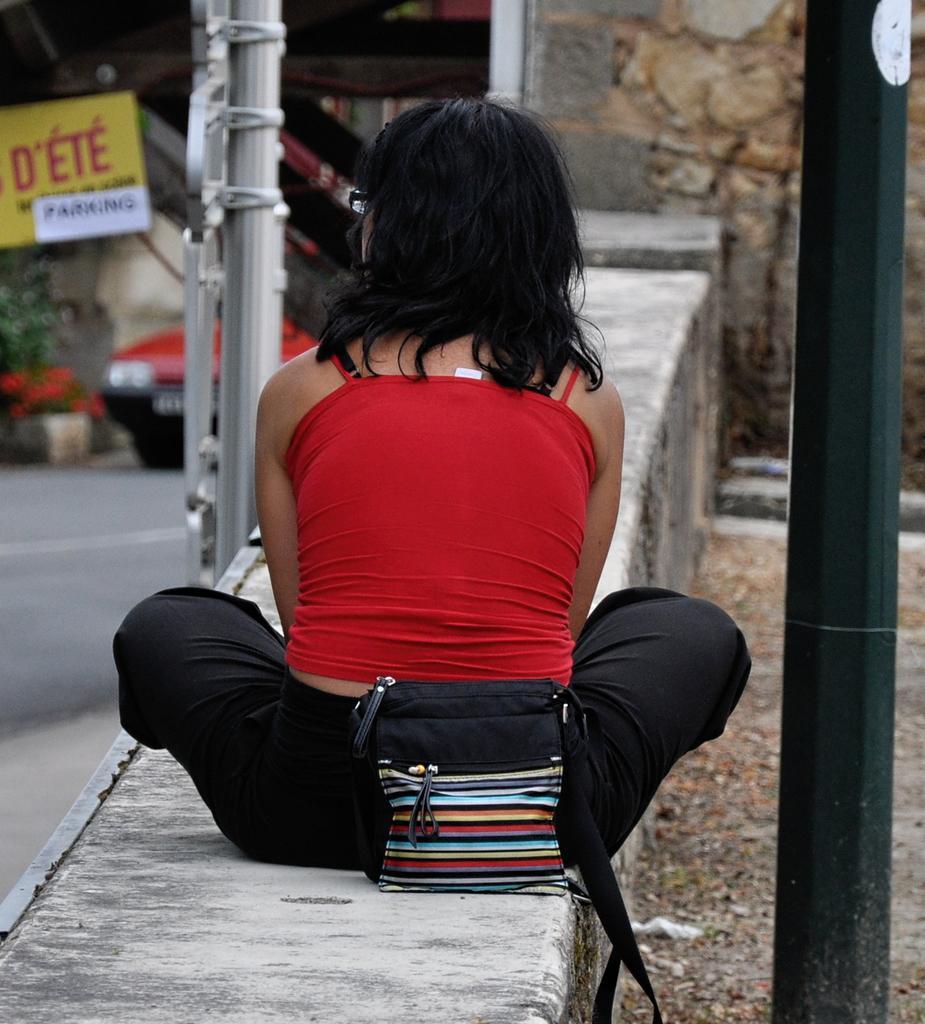Describe this image in one or two sentences. The picture is taken outside of the road where one woman is sitting on the wall wearing red t-shirt and carrying a bag and in front of her there is a vehicle and some plants and a sign board. 